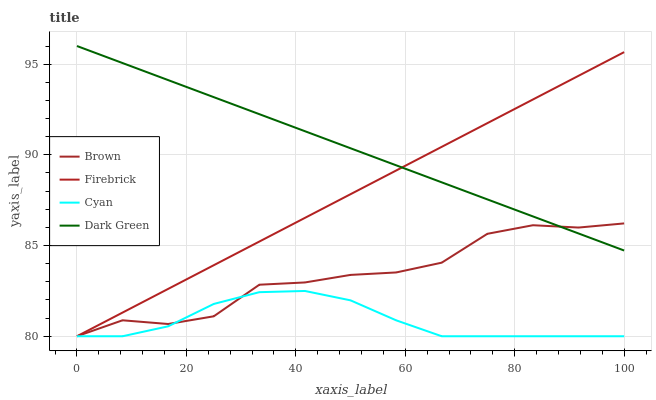Does Cyan have the minimum area under the curve?
Answer yes or no. Yes. Does Dark Green have the maximum area under the curve?
Answer yes or no. Yes. Does Firebrick have the minimum area under the curve?
Answer yes or no. No. Does Firebrick have the maximum area under the curve?
Answer yes or no. No. Is Firebrick the smoothest?
Answer yes or no. Yes. Is Brown the roughest?
Answer yes or no. Yes. Is Dark Green the smoothest?
Answer yes or no. No. Is Dark Green the roughest?
Answer yes or no. No. Does Brown have the lowest value?
Answer yes or no. Yes. Does Dark Green have the lowest value?
Answer yes or no. No. Does Dark Green have the highest value?
Answer yes or no. Yes. Does Firebrick have the highest value?
Answer yes or no. No. Is Cyan less than Dark Green?
Answer yes or no. Yes. Is Dark Green greater than Cyan?
Answer yes or no. Yes. Does Firebrick intersect Dark Green?
Answer yes or no. Yes. Is Firebrick less than Dark Green?
Answer yes or no. No. Is Firebrick greater than Dark Green?
Answer yes or no. No. Does Cyan intersect Dark Green?
Answer yes or no. No. 